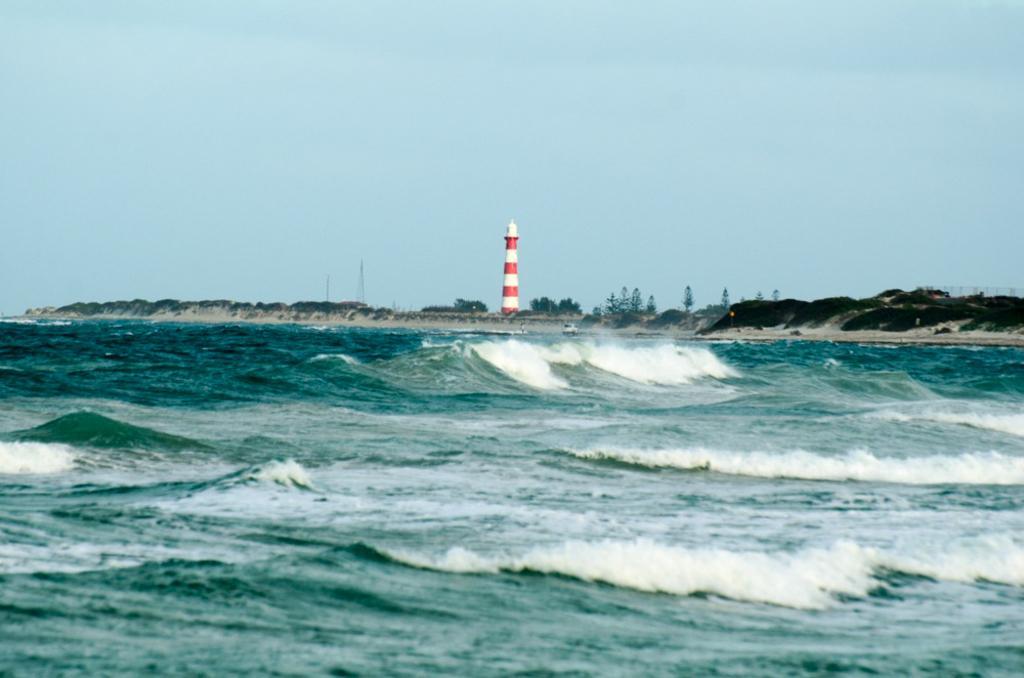Could you give a brief overview of what you see in this image? This picture is clicked outside the city. In the foreground we can see the water body. In the center we can see the trees, plants, rocks and an object. In the background there is a sky. 